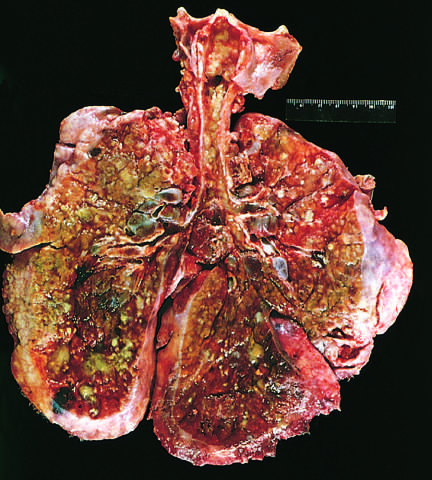s the greenish discoloration the product of pseudomonas infections?
Answer the question using a single word or phrase. Yes 